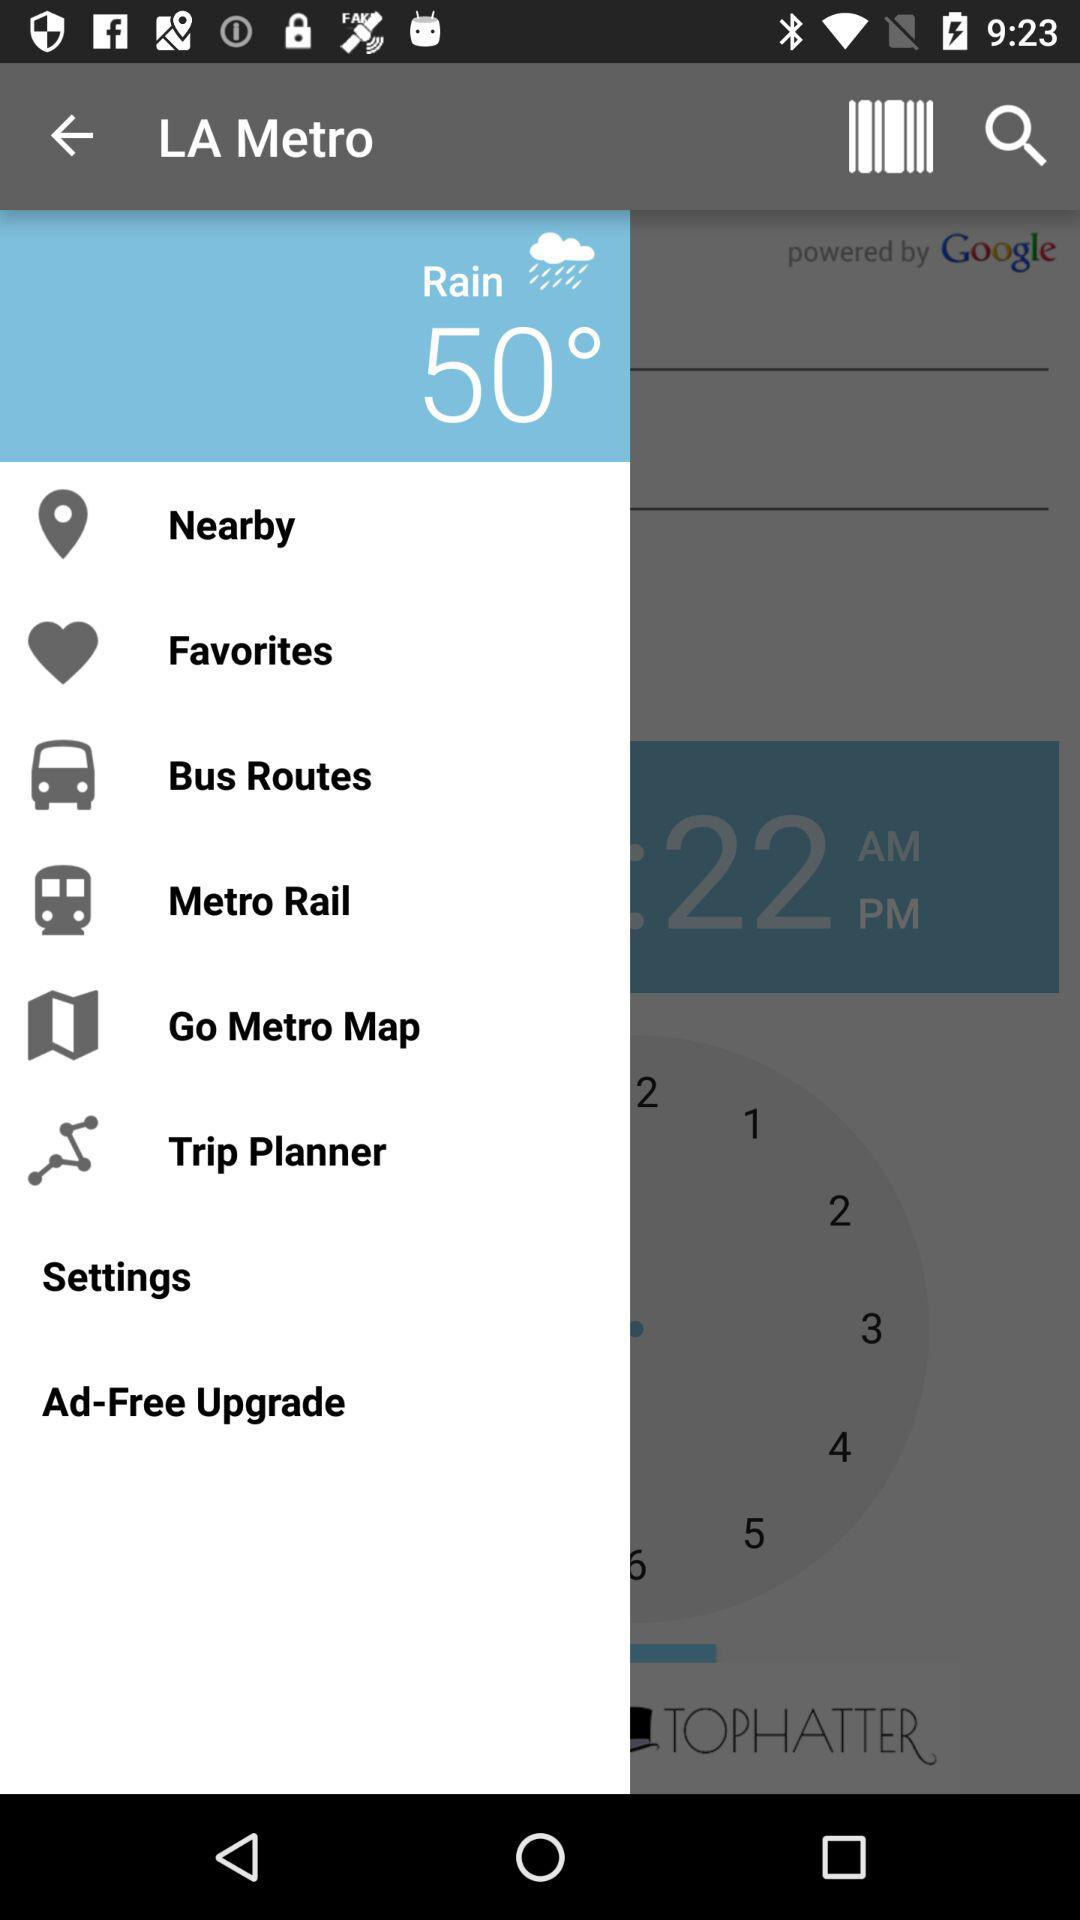What is the temperature? The temperature is 50 degrees. 